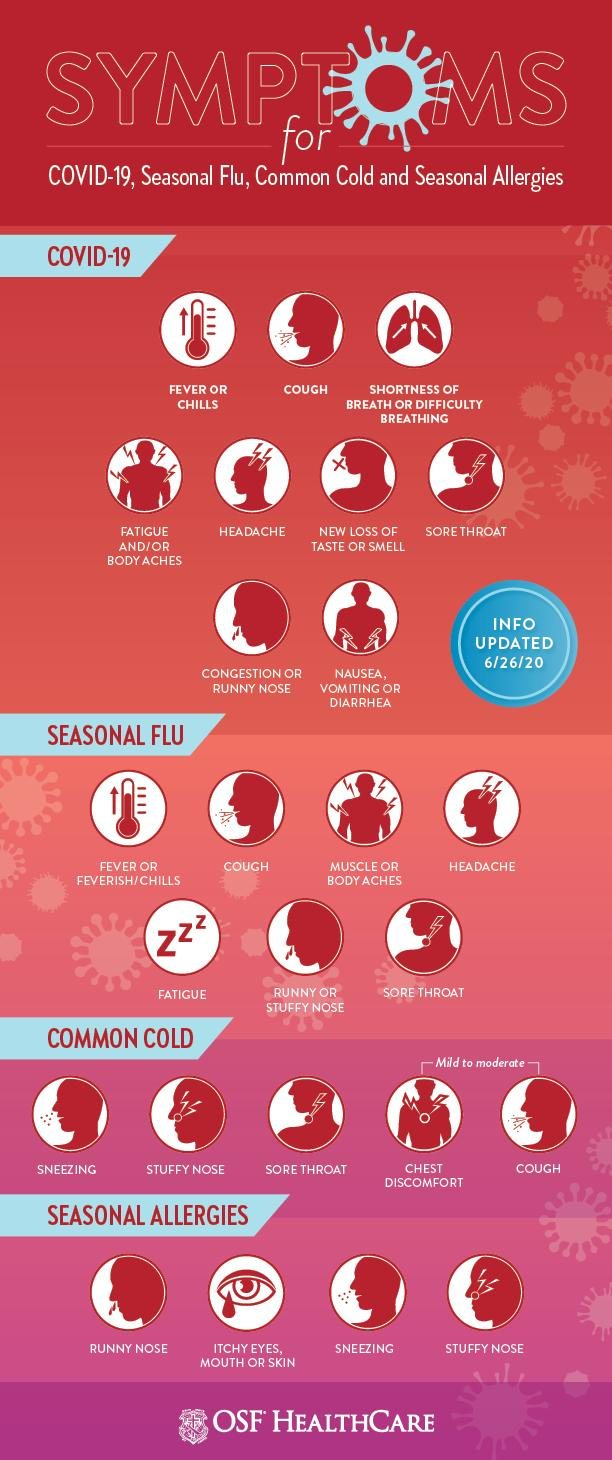Mention a couple of crucial points in this snapshot. COVID-19 and the common cold share several symptoms, including coughing and a sore throat. Symptoms of both cold and seasonal allergies, such as sneezing and a stuffy nose, are common. 